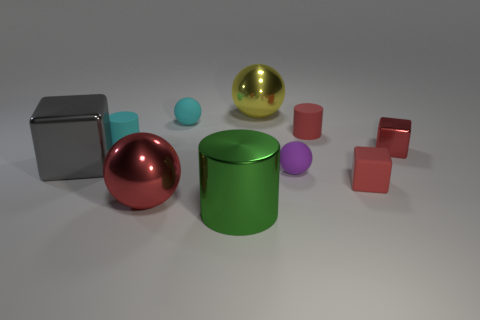Subtract all red rubber cylinders. How many cylinders are left? 2 Subtract all cylinders. How many objects are left? 7 Add 9 cyan cylinders. How many cyan cylinders exist? 10 Subtract all red cylinders. How many cylinders are left? 2 Subtract 0 blue cylinders. How many objects are left? 10 Subtract 3 cylinders. How many cylinders are left? 0 Subtract all gray cubes. Subtract all blue cylinders. How many cubes are left? 2 Subtract all green balls. How many gray blocks are left? 1 Subtract all gray shiny things. Subtract all green things. How many objects are left? 8 Add 3 cylinders. How many cylinders are left? 6 